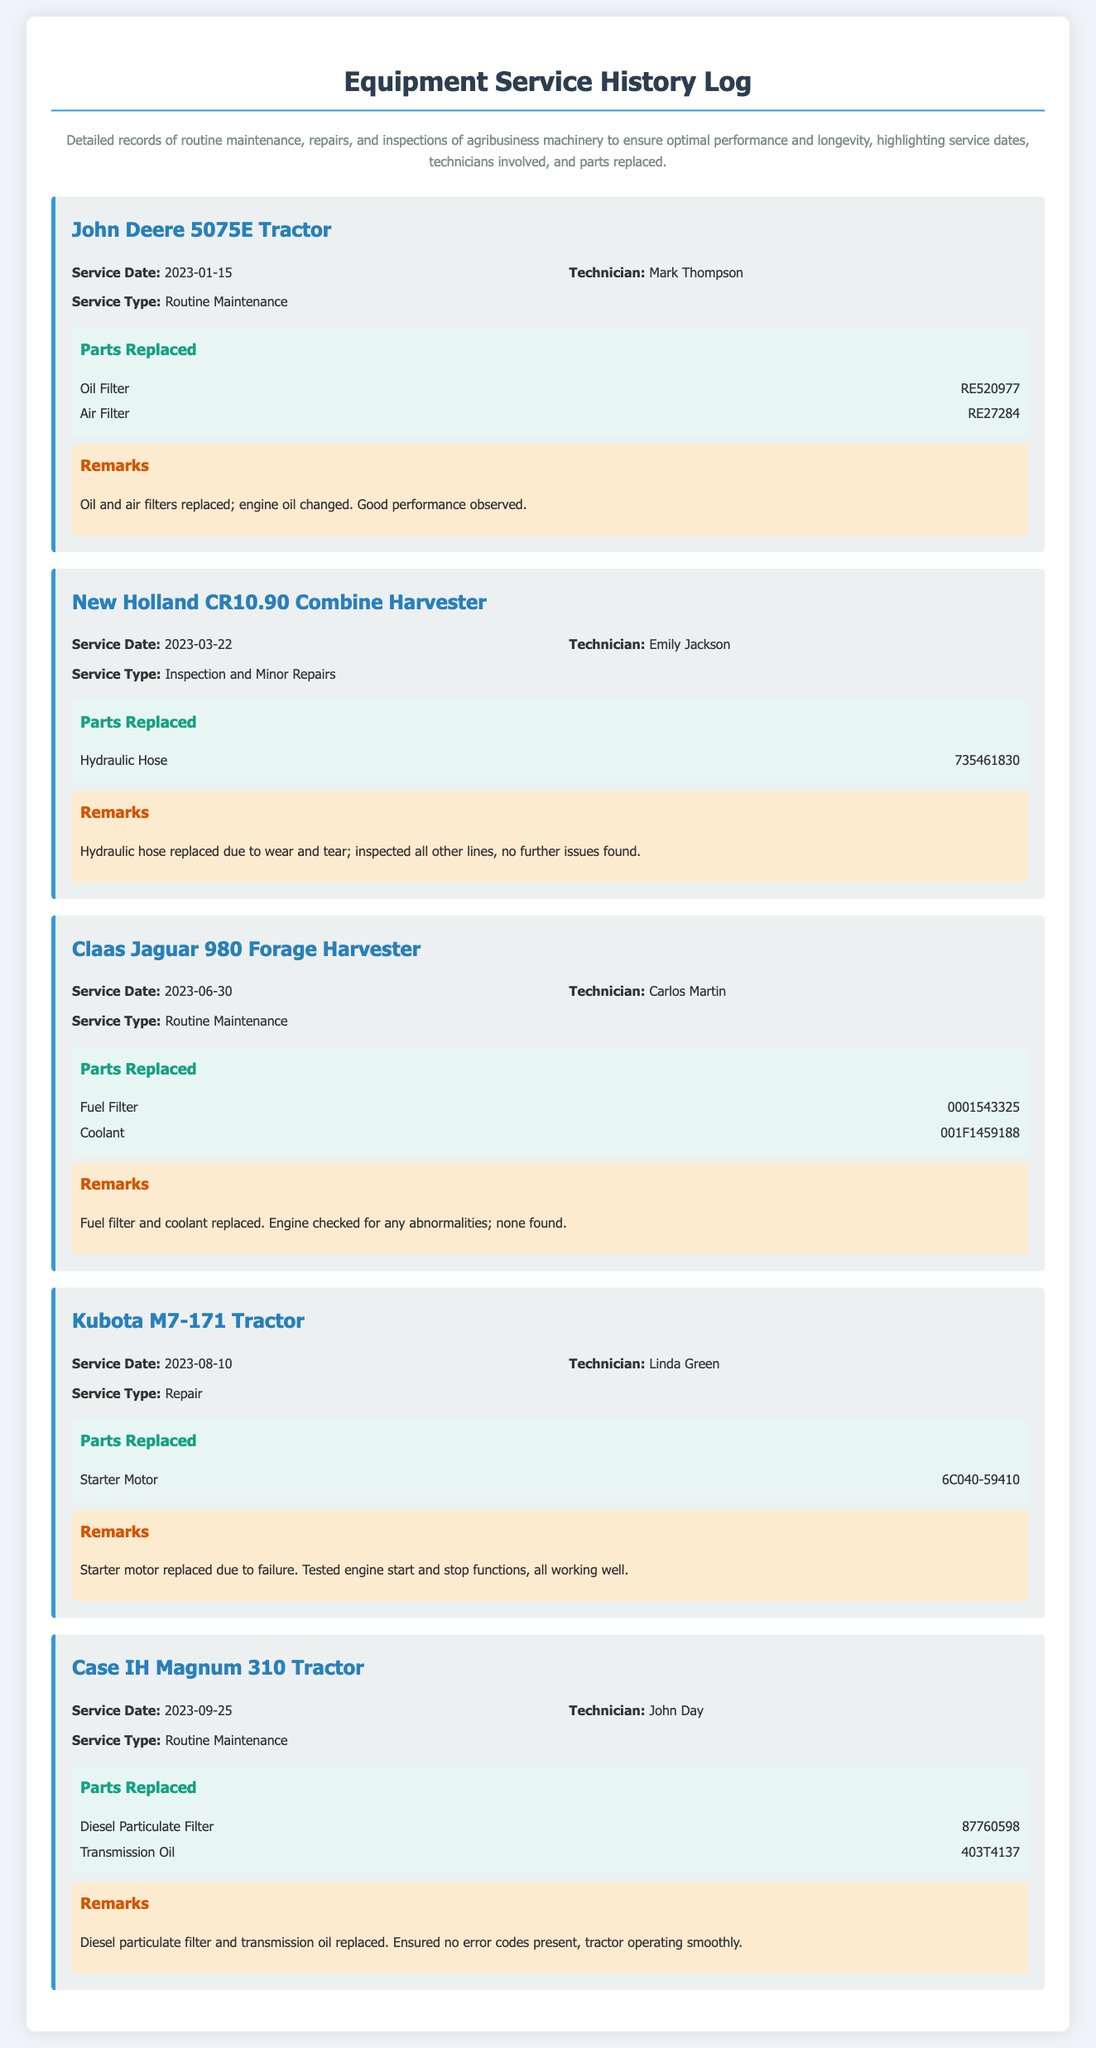What is the service date of the John Deere 5075E Tractor? The service date for the John Deere 5075E Tractor is specifically listed in the log entry.
Answer: 2023-01-15 Who was the technician for the New Holland CR10.90 Combine Harvester? The technician for the New Holland CR10.90 Combine Harvester is mentioned in the log entry.
Answer: Emily Jackson What parts were replaced during the service of the Claas Jaguar 980 Forage Harvester? The log entry provides detailed information about the parts replaced.
Answer: Fuel Filter, Coolant How many parts were replaced in the service of the Kubota M7-171 Tractor? The log entry outlines the number of parts replaced during the service.
Answer: 1 What type of service was performed on the Case IH Magnum 310 Tractor? The specific type of service performed is recorded in the log entry for the tractor.
Answer: Routine Maintenance Which tractor had a starter motor replaced? The log specifically mentions the tractor that had the starter motor replaced.
Answer: Kubota M7-171 Tractor On what date was the last service performed? The last service date mentioned in the log provides the answer to this question.
Answer: 2023-09-25 What was the remark for the service of the New Holland CR10.90 Combine Harvester? The remarks provide insights into what was noted during the service of the Combine Harvester.
Answer: Hydraulic hose replaced due to wear and tear; inspected all other lines, no further issues found 